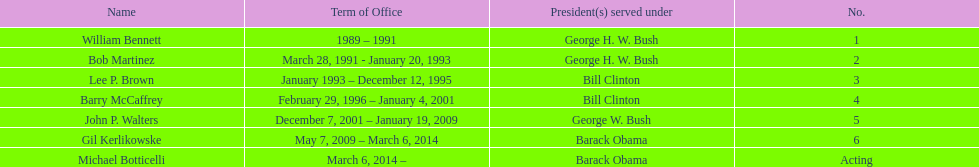How many directors had a tenure exceeding 3 years? 3. 